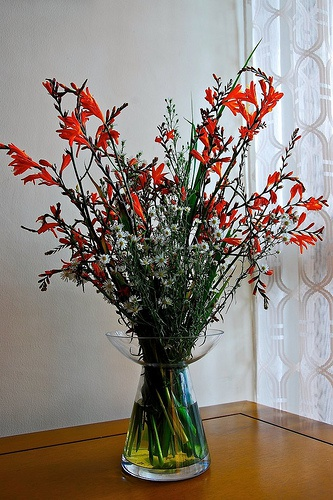Describe the objects in this image and their specific colors. I can see dining table in gray, maroon, and olive tones and vase in gray, black, olive, and darkgray tones in this image. 